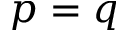<formula> <loc_0><loc_0><loc_500><loc_500>p = q</formula> 